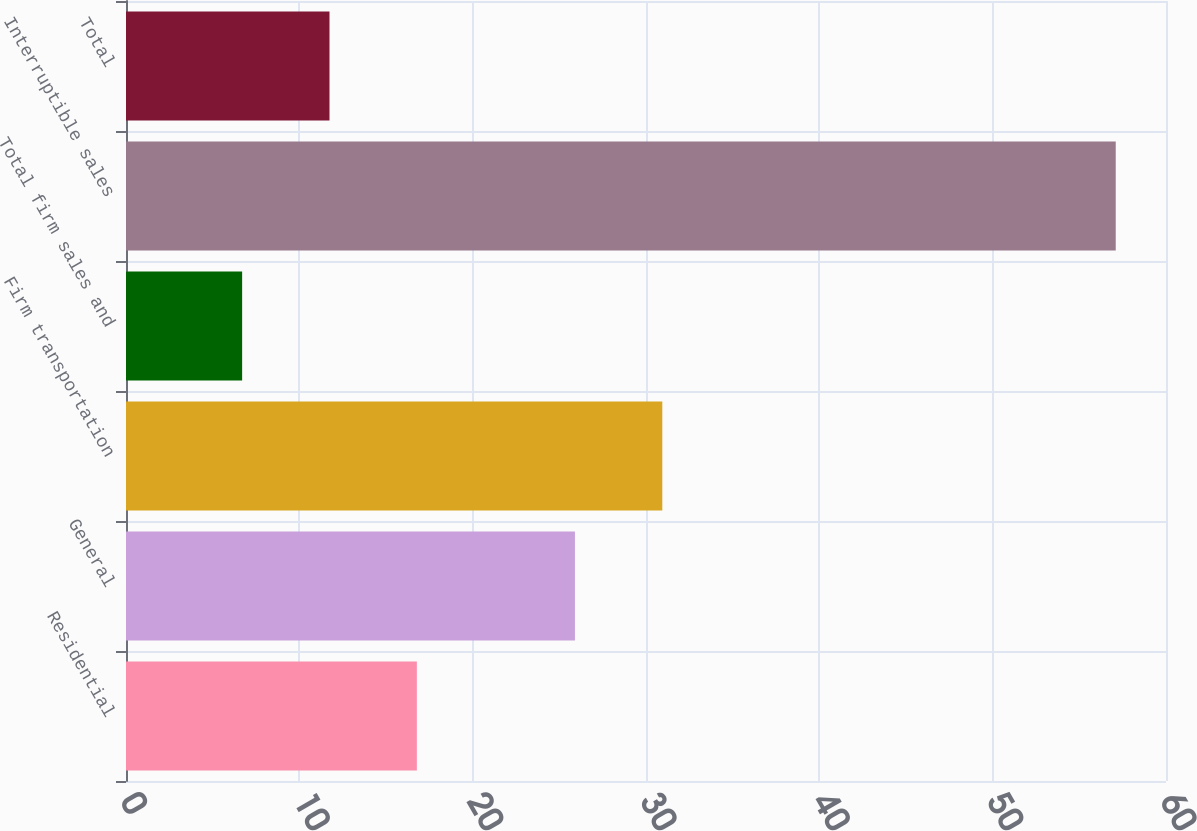Convert chart. <chart><loc_0><loc_0><loc_500><loc_500><bar_chart><fcel>Residential<fcel>General<fcel>Firm transportation<fcel>Total firm sales and<fcel>Interruptible sales<fcel>Total<nl><fcel>16.78<fcel>25.9<fcel>30.94<fcel>6.7<fcel>57.1<fcel>11.74<nl></chart> 